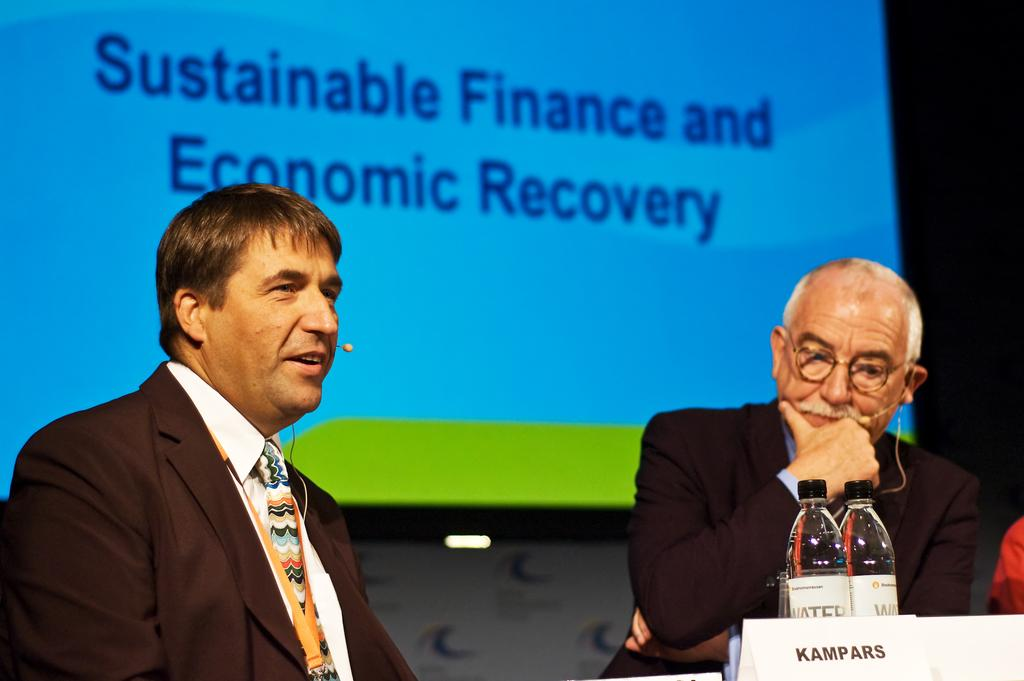How many people are in the image? There are two persons in the image. What objects are in front of the persons? There are water bottles and a name board in front of the persons. What can be seen in the background of the image? There is a presentation screen in the background of the image. What type of vase is placed on the presentation screen? There is no vase present on the presentation screen in the image. 